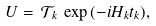Convert formula to latex. <formula><loc_0><loc_0><loc_500><loc_500>U = \, \mathcal { T } _ { k } \, \exp { ( - i H _ { k } t _ { k } ) } ,</formula> 